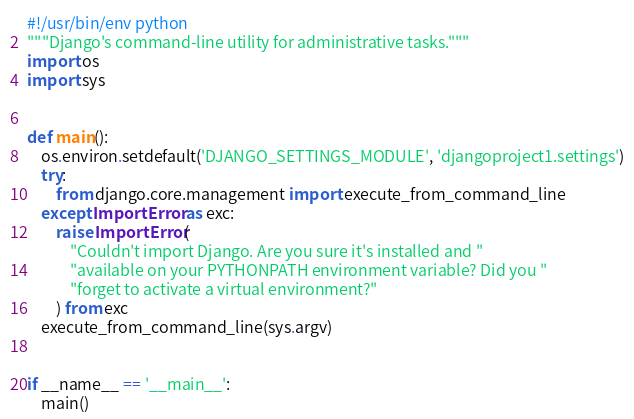Convert code to text. <code><loc_0><loc_0><loc_500><loc_500><_Python_>#!/usr/bin/env python
"""Django's command-line utility for administrative tasks."""
import os
import sys


def main():
    os.environ.setdefault('DJANGO_SETTINGS_MODULE', 'djangoproject1.settings')
    try:
        from django.core.management import execute_from_command_line
    except ImportError as exc:
        raise ImportError(
            "Couldn't import Django. Are you sure it's installed and "
            "available on your PYTHONPATH environment variable? Did you "
            "forget to activate a virtual environment?"
        ) from exc
    execute_from_command_line(sys.argv)


if __name__ == '__main__':
    main()
</code> 